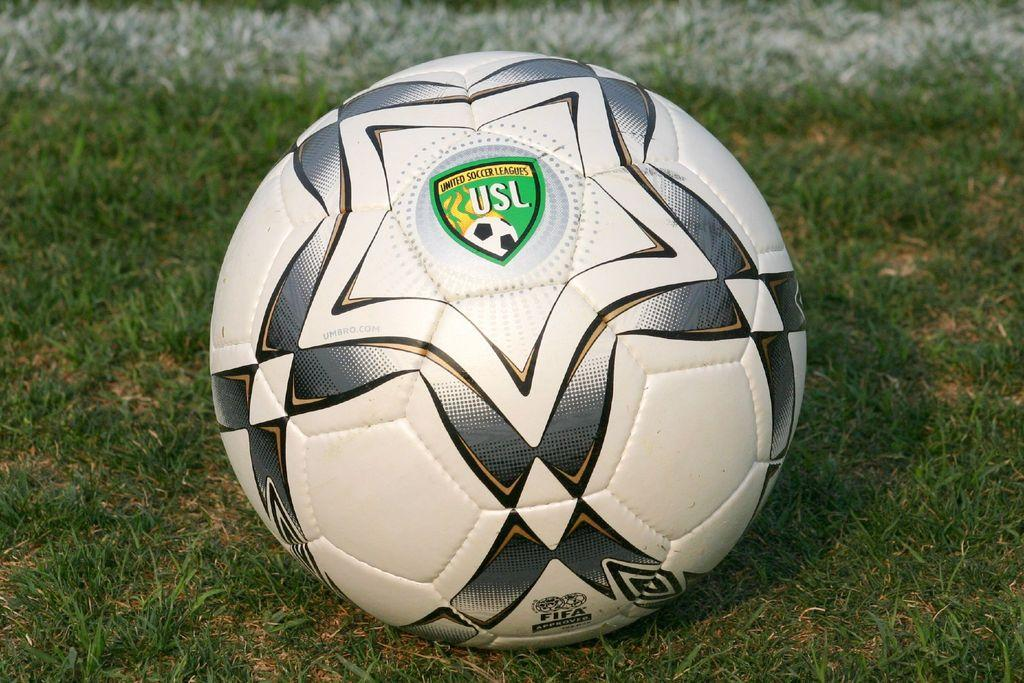What is the main object in the image? There is a football in the image. Where is the football located? The football is on the grass. How close is the football to the viewer? The football is in the foreground of the image, which means it is close to the viewer. How many straws are used to decorate the football in the image? There are no straws present in the image, as it features a football on the grass. What type of insect can be seen crawling on the football in the image? There are no insects, including ladybugs, visible on the football in the image. 